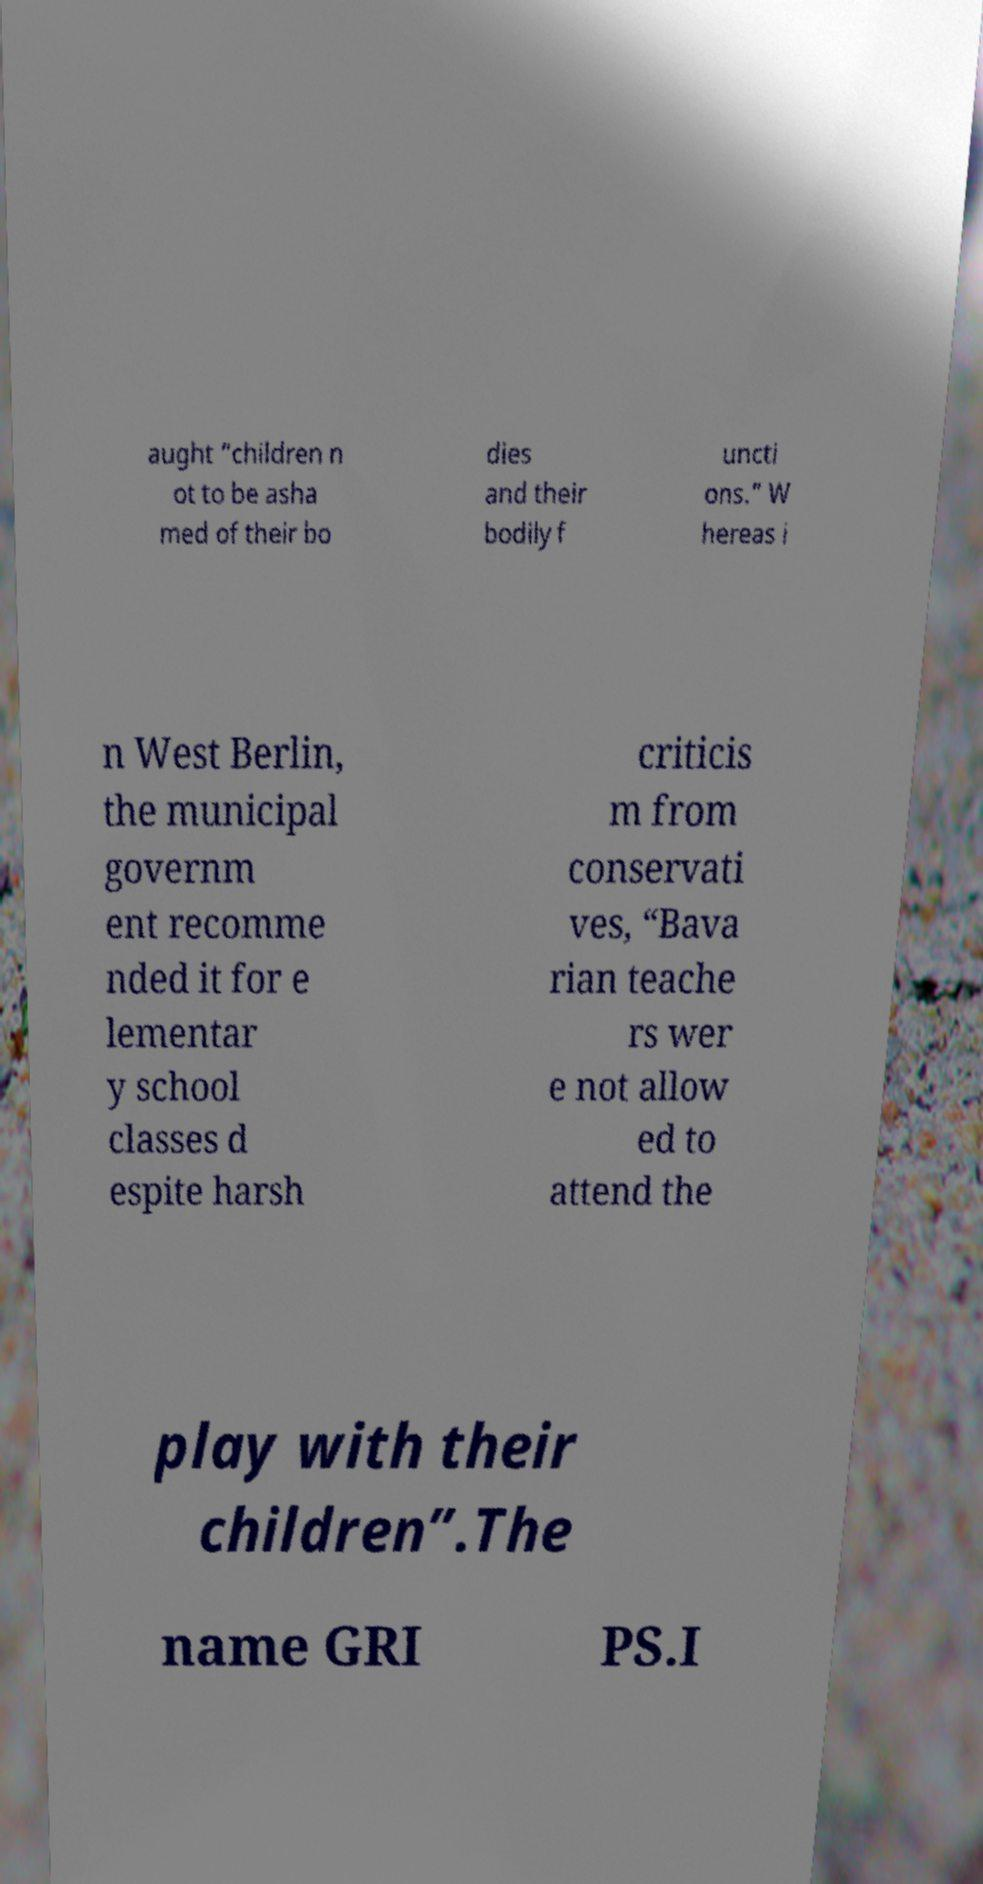Can you accurately transcribe the text from the provided image for me? aught “children n ot to be asha med of their bo dies and their bodily f uncti ons.” W hereas i n West Berlin, the municipal governm ent recomme nded it for e lementar y school classes d espite harsh criticis m from conservati ves, “Bava rian teache rs wer e not allow ed to attend the play with their children”.The name GRI PS.I 